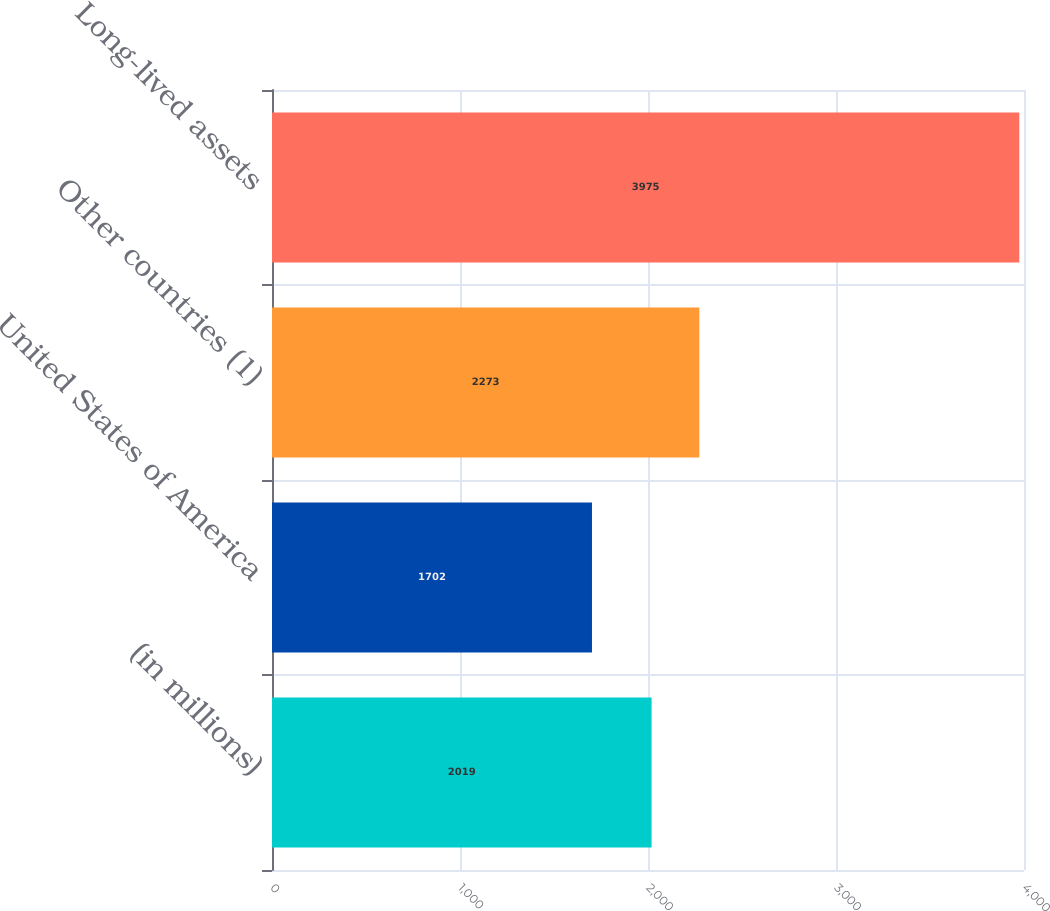<chart> <loc_0><loc_0><loc_500><loc_500><bar_chart><fcel>(in millions)<fcel>United States of America<fcel>Other countries (1)<fcel>Long-lived assets<nl><fcel>2019<fcel>1702<fcel>2273<fcel>3975<nl></chart> 